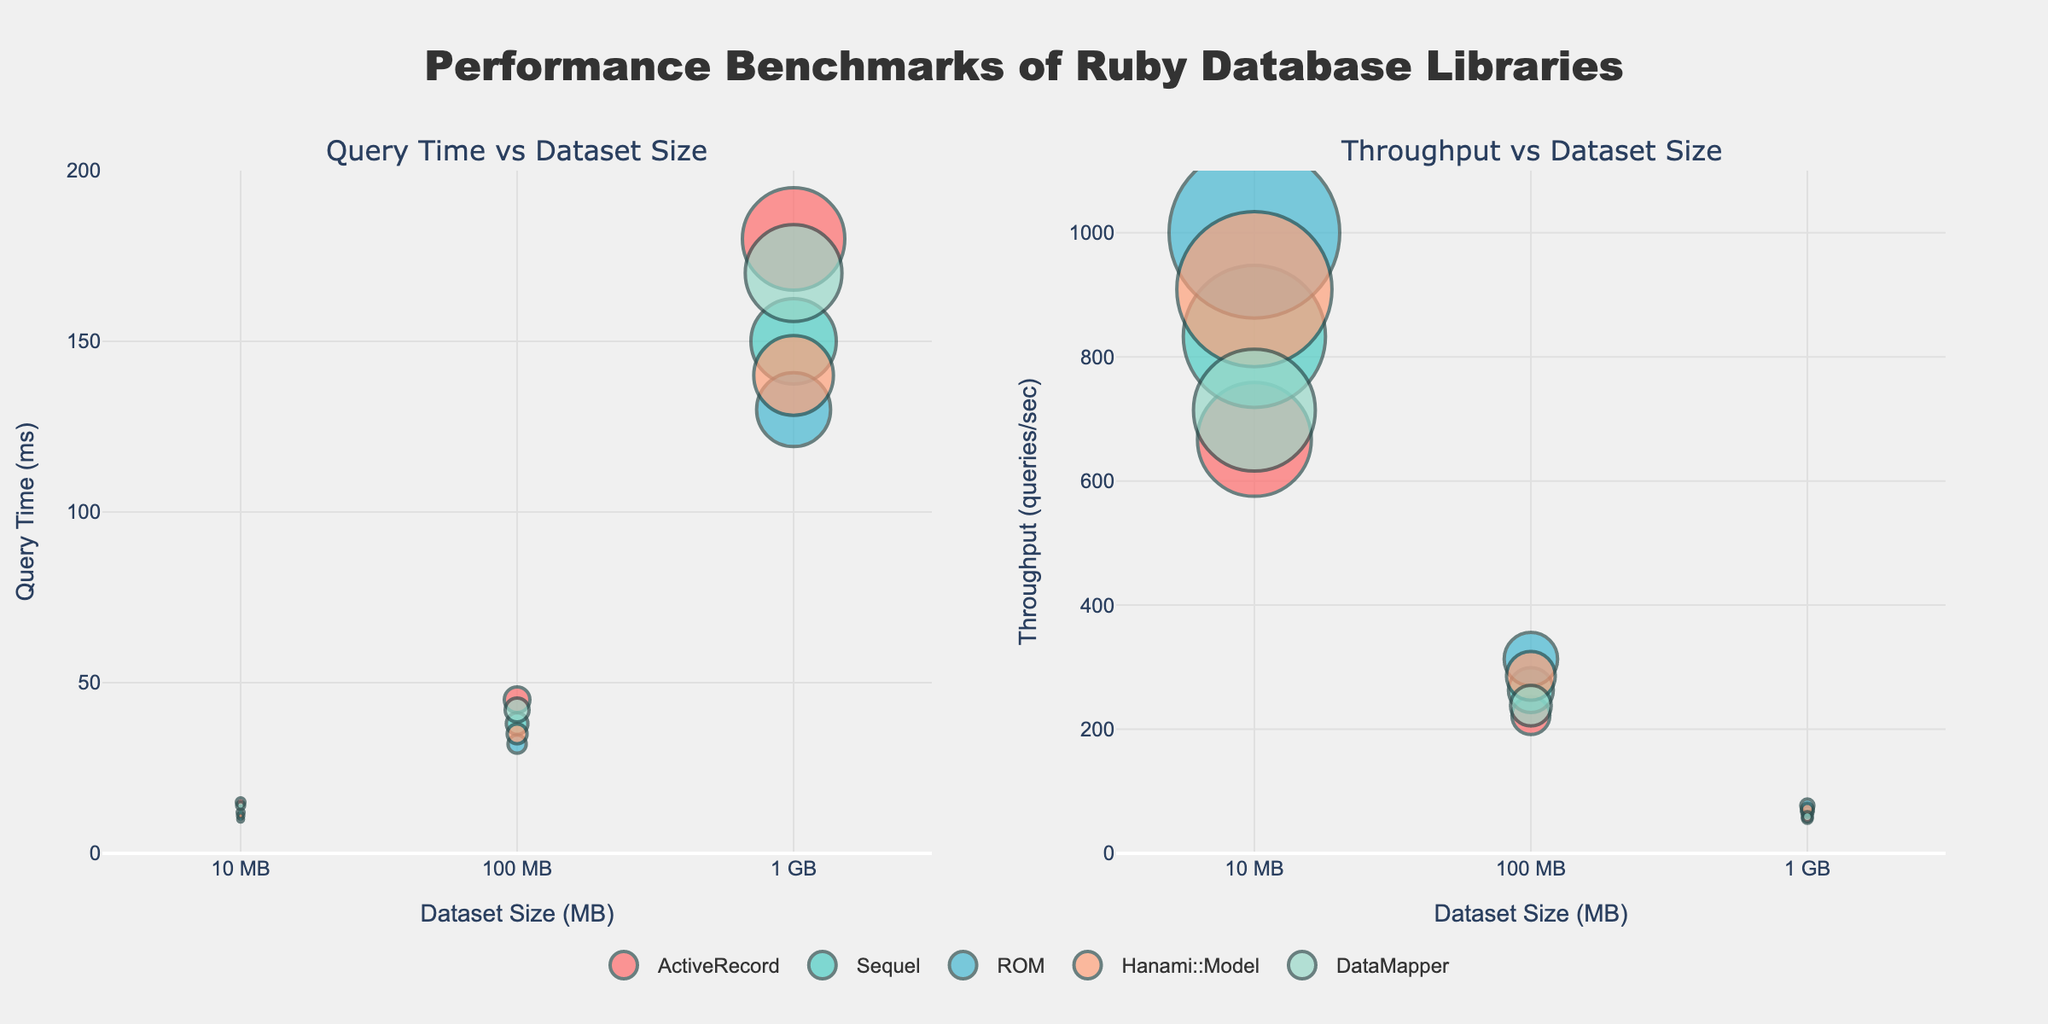How many hours of sleep do most students get? The scatterplot matrix shows various hours of sleep for different students. By observing the data points, it can be seen that the majority of students tend to get around 7-8 hours of sleep.
Answer: 7-8 hours Which student has the highest test score and how many hours of sleep did they get? The highest test score can be identified by the highest value on the test score axis. Morgan has the highest test score of 95, and they get 9 hours of sleep.
Answer: Morgan, 9 hours Is there any student who scores above 90 and exercises less than 100 minutes per week? By checking students who have test scores above 90 on the test score axis and then cross-referencing with the exercise minutes per week axis, there are no students who meet these criteria.
Answer: No Which student exercises the most and what is their test score? The student who exercises the most will be at the farthest right on the exercise axis. Morgan exercises 210 minutes per week and has a test score of 95.
Answer: Morgan, 95 How many students sleep for 5 hours? Count the data points along the Hours of Sleep axis that are at 5. There are four students who sleep for 5 hours.
Answer: 4 students Which student gets 7 hours of sleep and has the lowest test score among those with 7 hours of sleep? Looking at the data points for 7 hours of sleep, find the lowest value on the test score axis. Drew has a test score of 84 which is the lowest among those who sleep 7 hours.
Answer: Drew, 84 What is the relationship between exercise frequency and test performance? By looking at the general trend in the scatterplot matrix between Exercise_Minutes_per_Week and Test_Score, it's observed that generally, students who exercise more tend to have higher test scores indicating a positive relationship.
Answer: Positive relationship Compare the test scores of students who sleep 5 hours to those who sleep 9 hours. Use the scatterplot to identify the test scores for students with 5 and 9 hours of sleep. Students with 5 hours of sleep have test scores of 72, 70, 71, 69, while those with 9 hours of sleep have test scores of 95 and 94.
Answer: 5 hours: 72, 70, 71, 69. 9 hours: 95, 94 Are there any students who sleep 8 hours and have a test score of at least 90? Check the data points for 8 hours of sleep and see which ones have test scores of 90 or more. There are four students: Jordan, Quinn, Reese, and Riley.
Answer: Yes, 4 students (Jordan, Quinn, Reese, Riley) What is the average test score for students who exercise more than 150 minutes per week? Find the students who exercise more than 150 minutes per week, then sum their test scores and divide by the number of these students. Students: Jordan (92), Sam (88), Morgan (95), Riley (90), Cameron (94), Quinn (93), Reese (91). Average = (92+88+95+90+94+93+91)/7 = 91.86
Answer: 91.86 